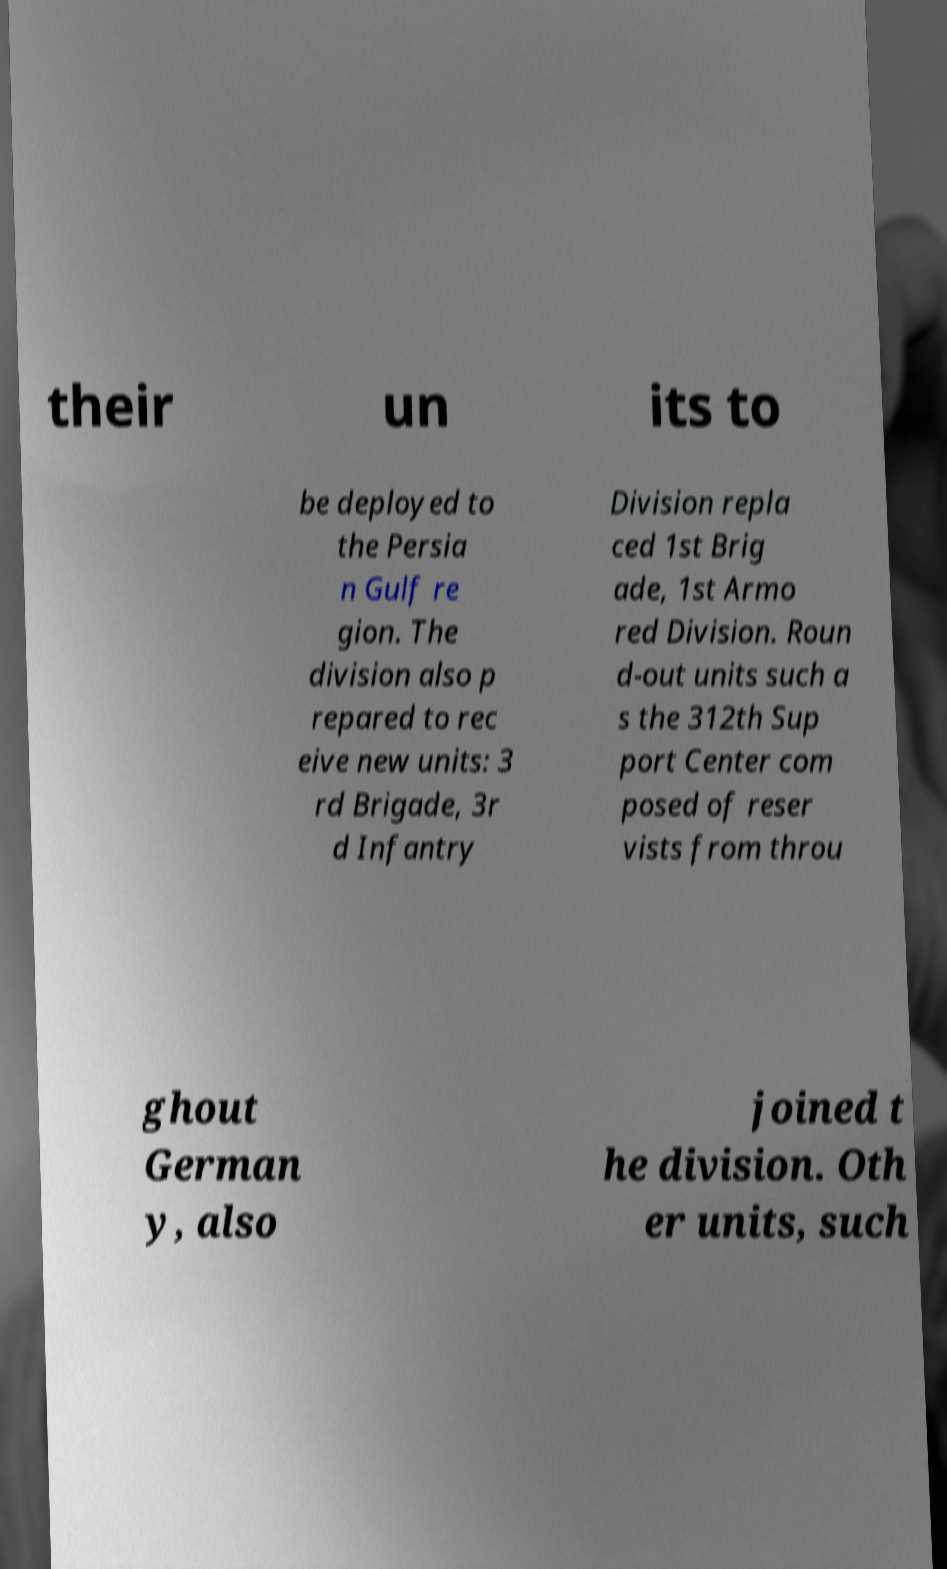Could you extract and type out the text from this image? their un its to be deployed to the Persia n Gulf re gion. The division also p repared to rec eive new units: 3 rd Brigade, 3r d Infantry Division repla ced 1st Brig ade, 1st Armo red Division. Roun d-out units such a s the 312th Sup port Center com posed of reser vists from throu ghout German y, also joined t he division. Oth er units, such 